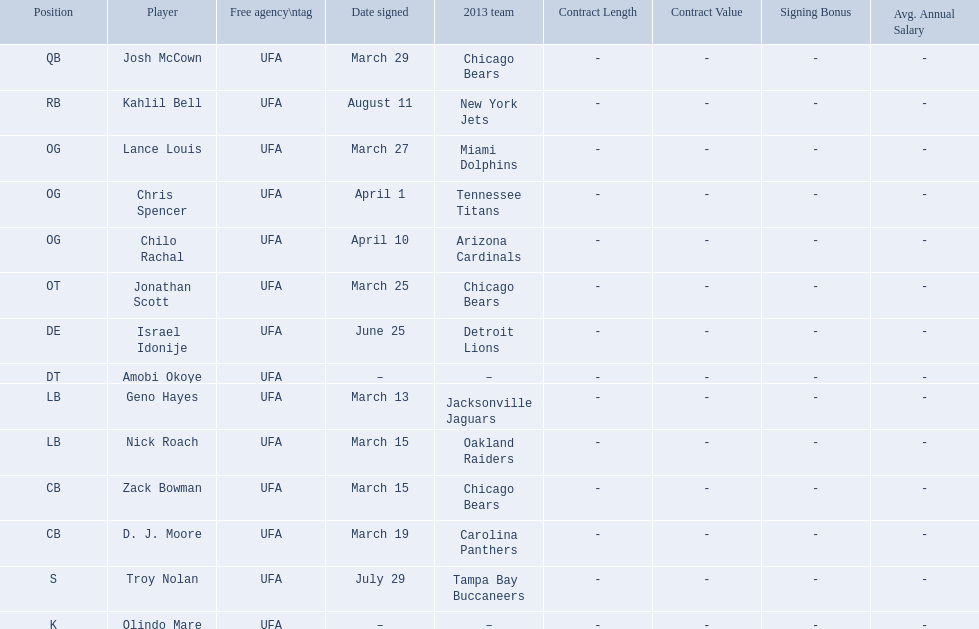Who are all of the players? Josh McCown, Kahlil Bell, Lance Louis, Chris Spencer, Chilo Rachal, Jonathan Scott, Israel Idonije, Amobi Okoye, Geno Hayes, Nick Roach, Zack Bowman, D. J. Moore, Troy Nolan, Olindo Mare. When were they signed? March 29, August 11, March 27, April 1, April 10, March 25, June 25, –, March 13, March 15, March 15, March 19, July 29, –. Along with nick roach, who else was signed on march 15? Zack Bowman. 